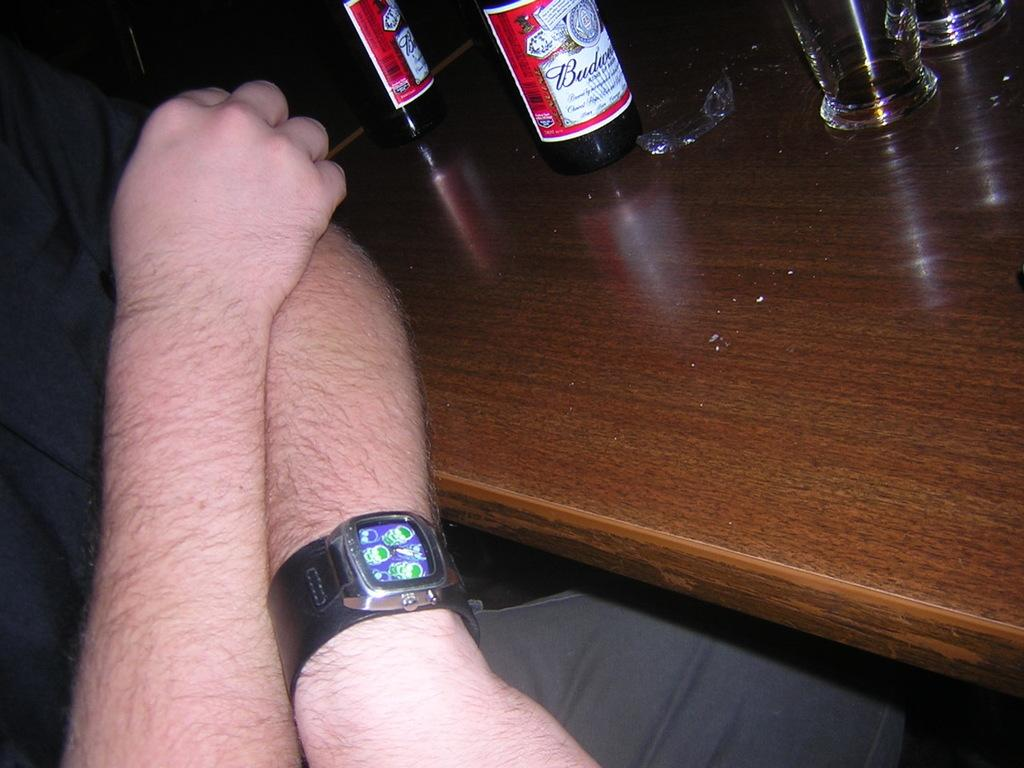<image>
Share a concise interpretation of the image provided. A person sitting next to a Budweiser bottle 